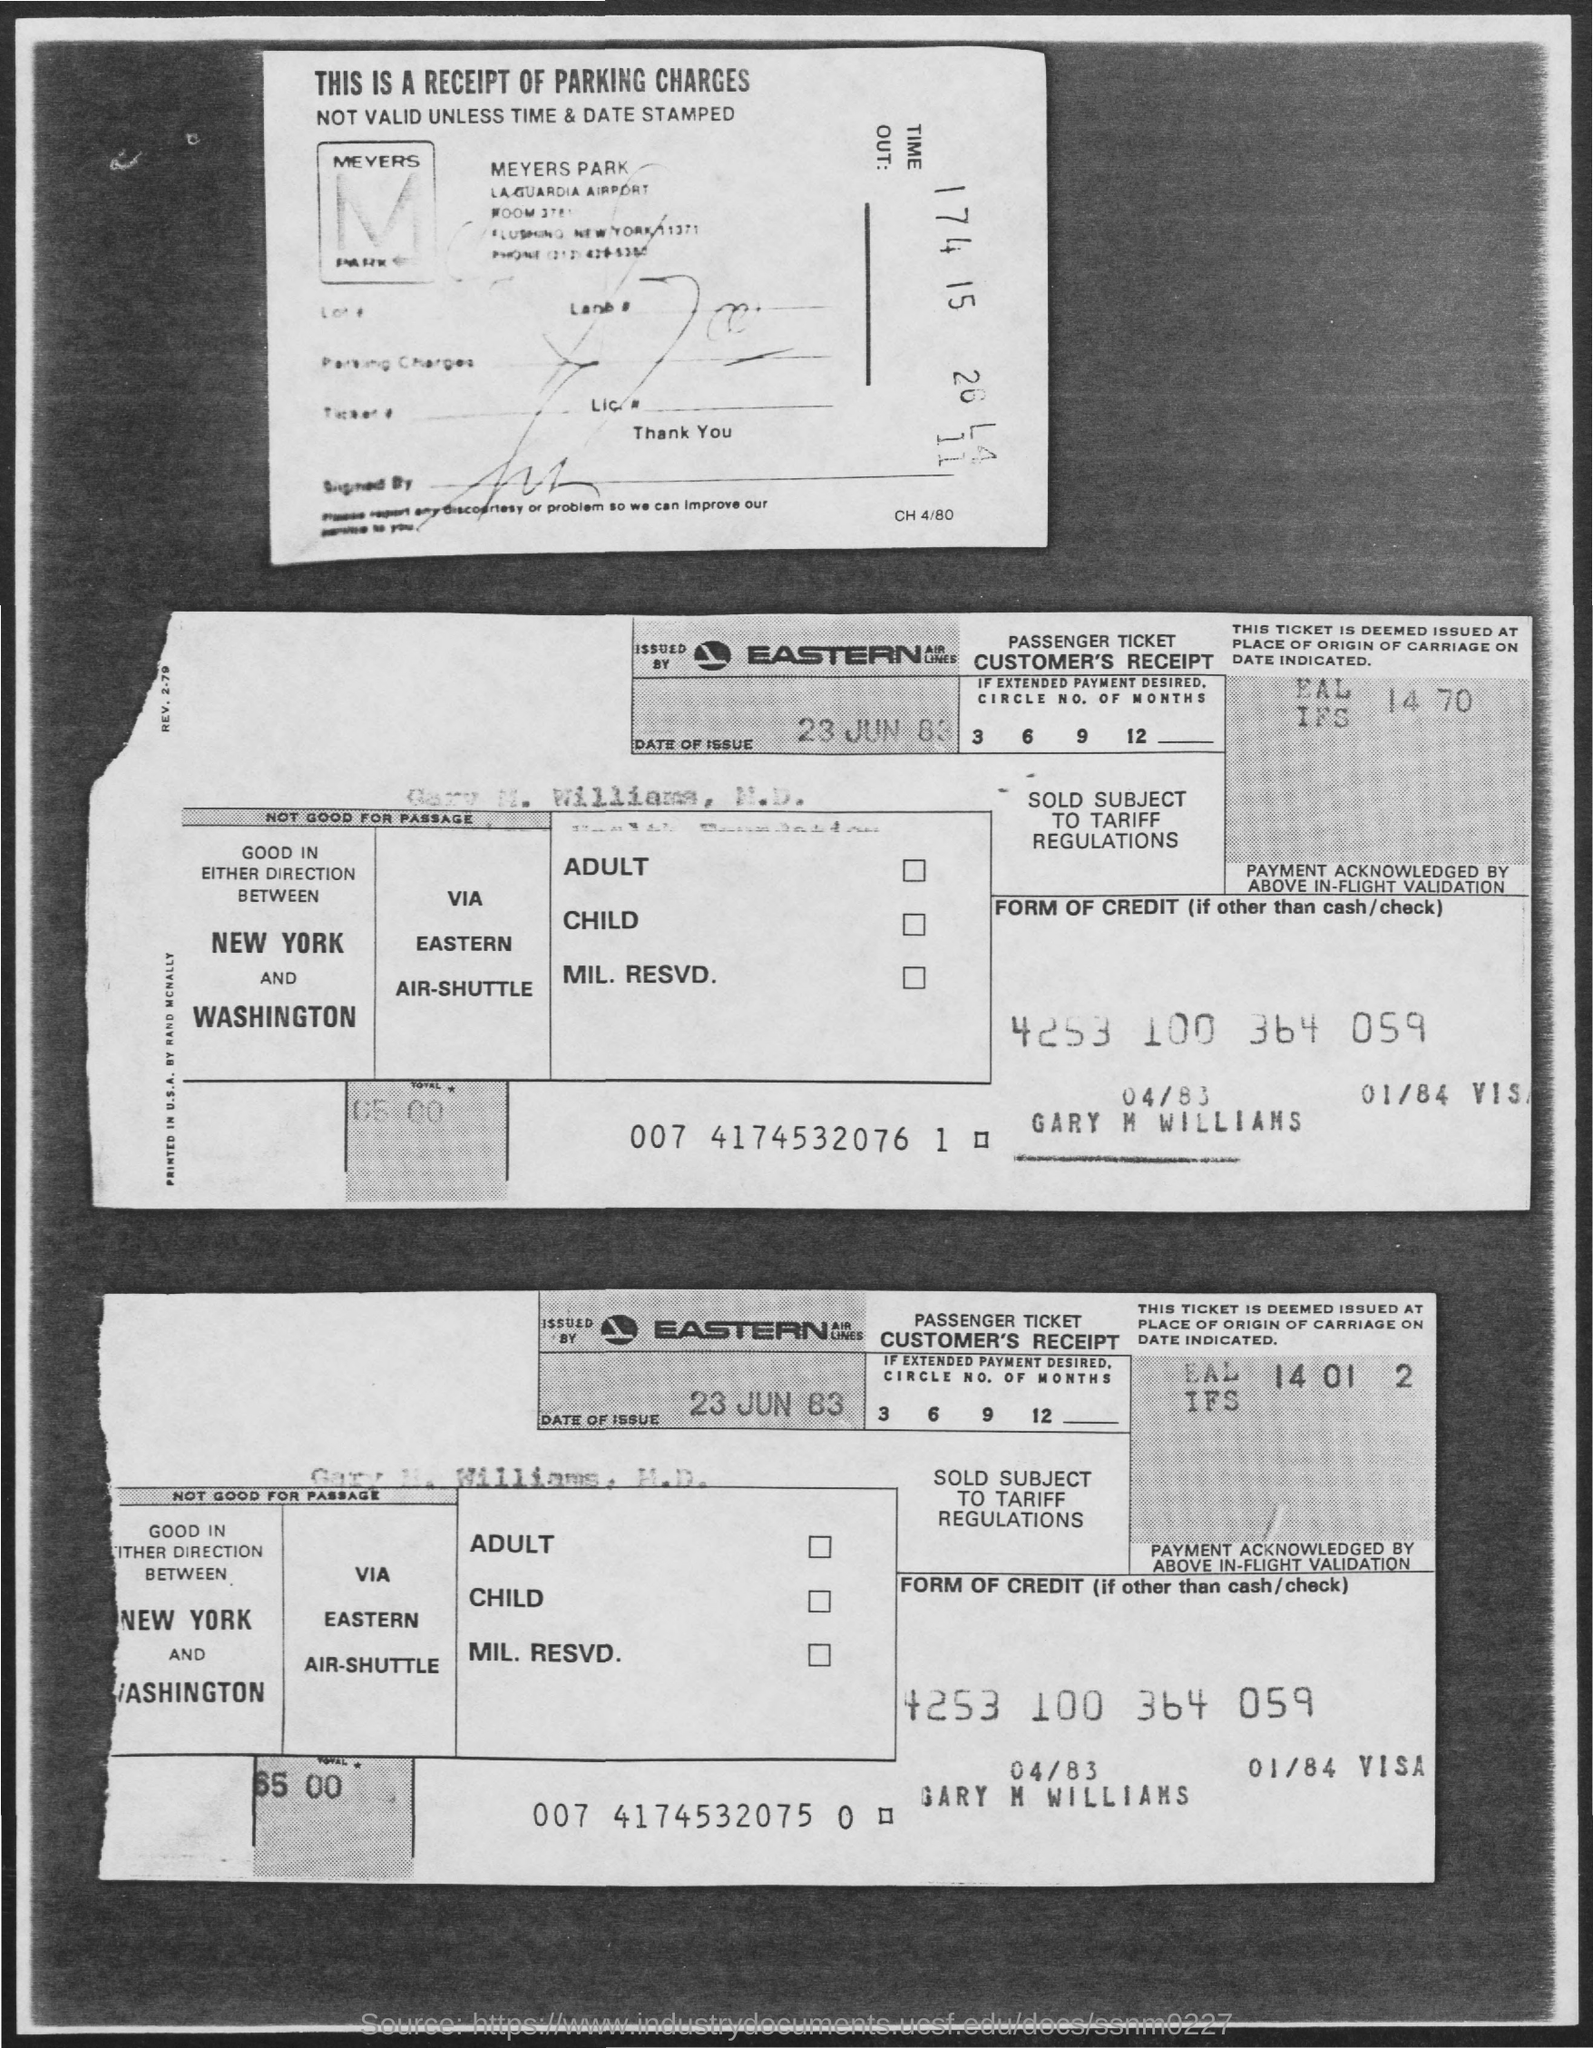What is the date of issue mentioned in the given page ?
Your answer should be compact. 23 jun 83. What is the total amount mentioned in the given form ?
Provide a short and direct response. 65 00. 